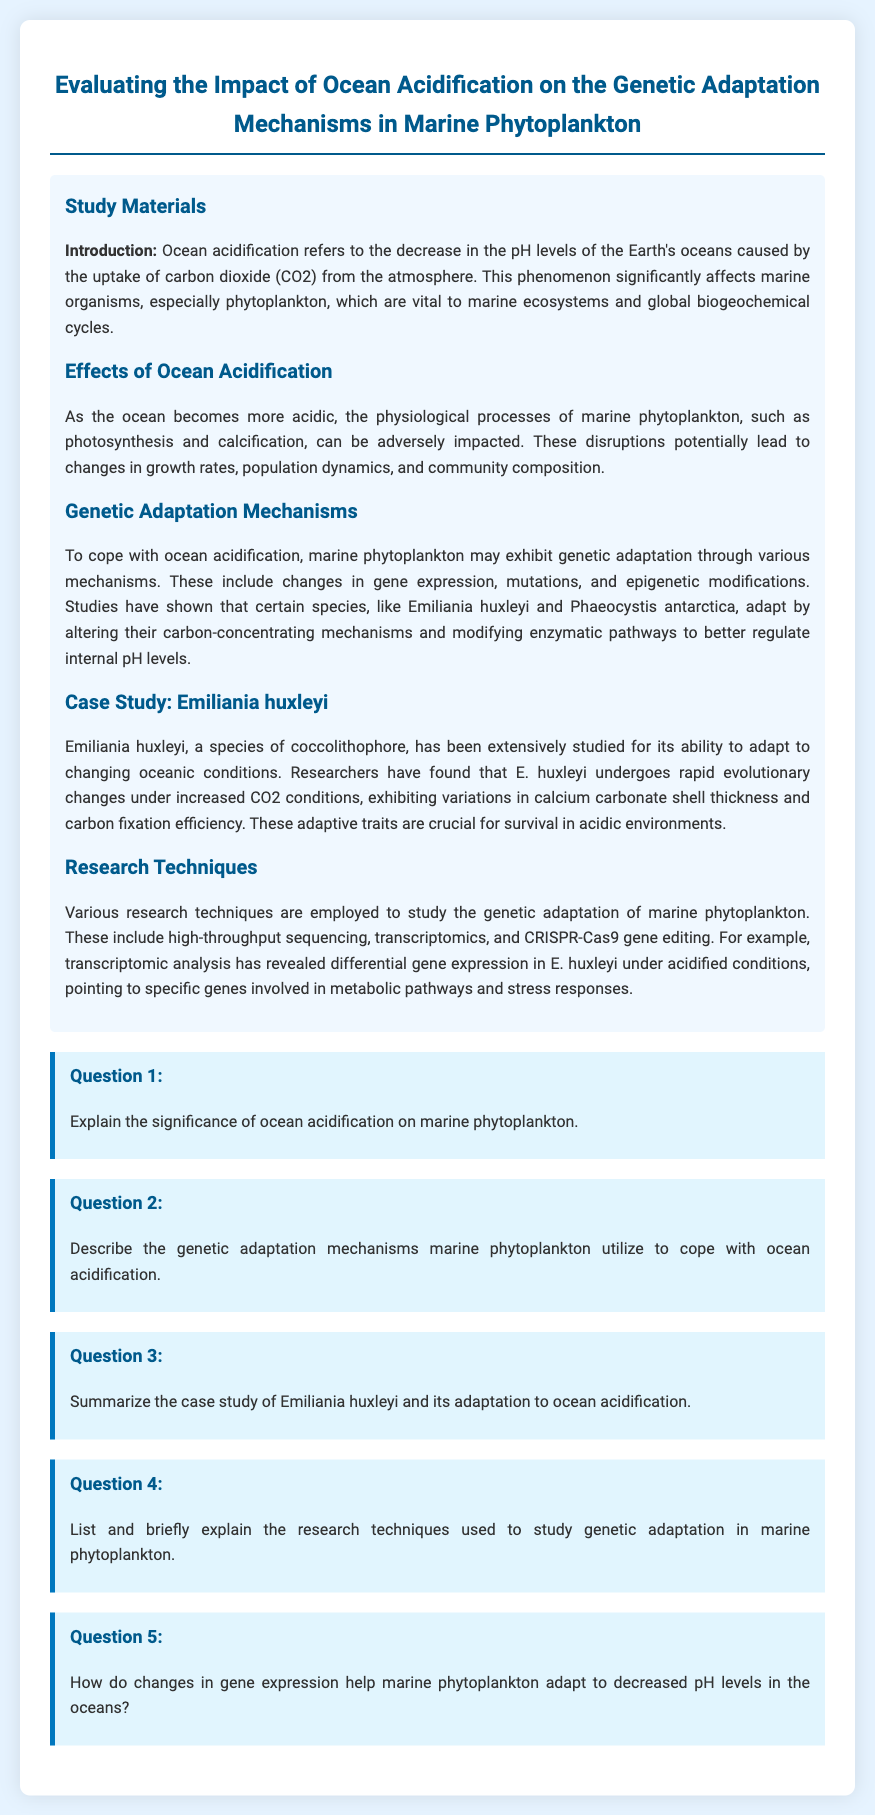What does ocean acidification refer to? Ocean acidification refers to the decrease in the pH levels of the Earth's oceans caused by the uptake of carbon dioxide (CO2) from the atmosphere.
Answer: decrease in pH levels What are two physiological processes impacted by ocean acidification? The document states that physiological processes such as photosynthesis and calcification can be adversely impacted by ocean acidification.
Answer: photosynthesis and calcification What species is extensively studied for adaptation to changing oceanic conditions? The document highlights Emiliania huxleyi as a species that has been extensively studied for its ability to adapt to changing oceanic conditions.
Answer: Emiliania huxleyi What research techniques are employed to study genetic adaptation? The document lists high-throughput sequencing, transcriptomics, and CRISPR-Cas9 gene editing as research techniques used to study genetic adaptation.
Answer: high-throughput sequencing, transcriptomics, and CRISPR-Cas9 gene editing How does E. huxleyi adapt to increased CO2 conditions? According to the case study, E. huxleyi undergoes rapid evolutionary changes under increased CO2 conditions, exhibiting variations in calcium carbonate shell thickness and carbon fixation efficiency.
Answer: rapid evolutionary changes Why are adaptive traits important for marine phytoplankton? The document indicates that adaptive traits are crucial for survival in acidic environments, which highlights their importance.
Answer: crucial for survival in acidic environments 